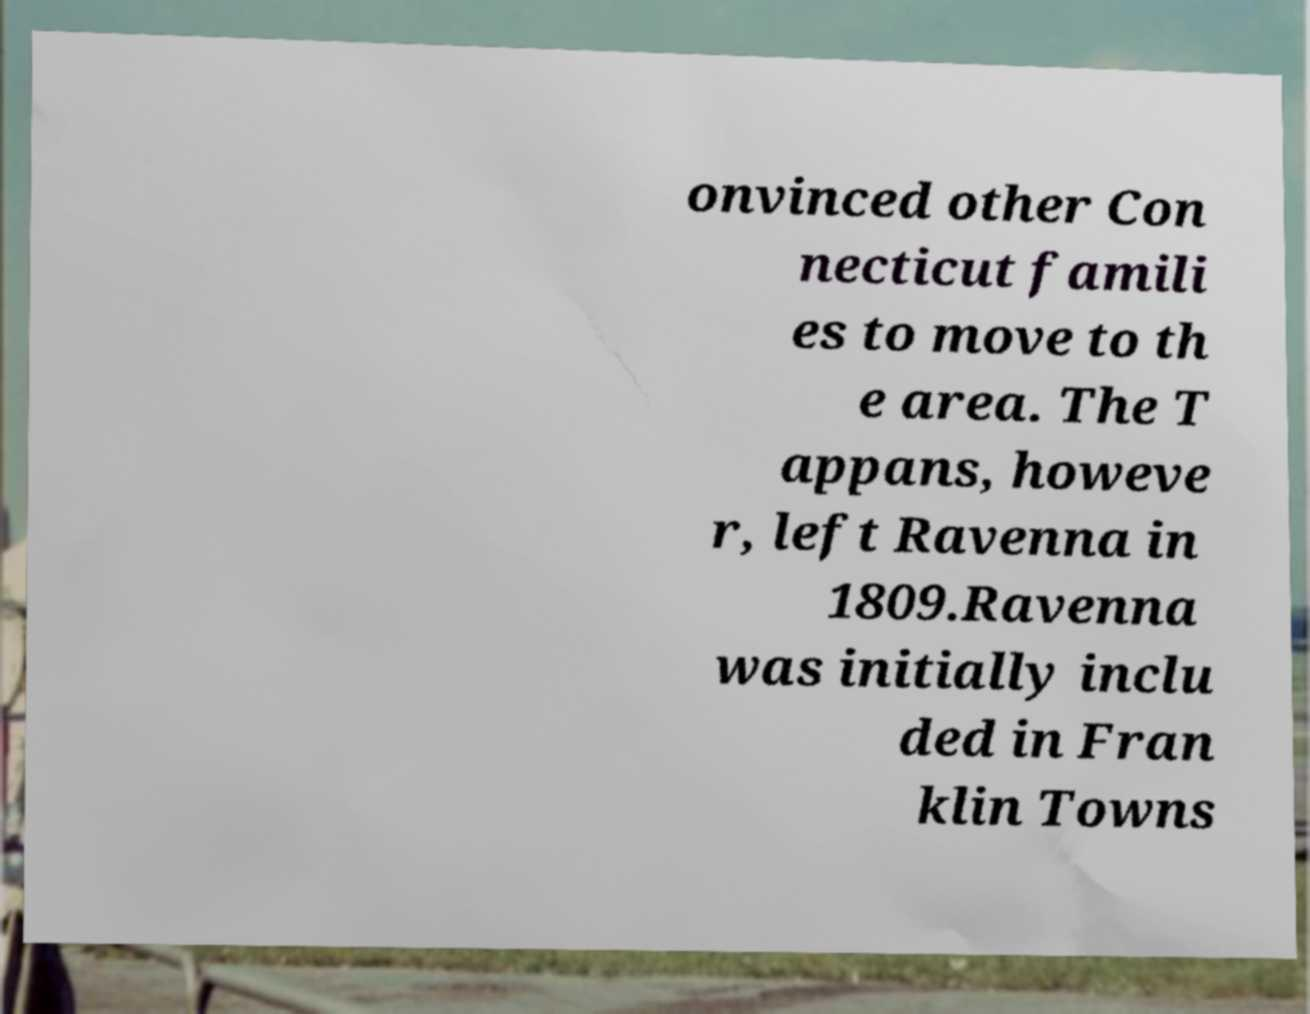I need the written content from this picture converted into text. Can you do that? onvinced other Con necticut famili es to move to th e area. The T appans, howeve r, left Ravenna in 1809.Ravenna was initially inclu ded in Fran klin Towns 